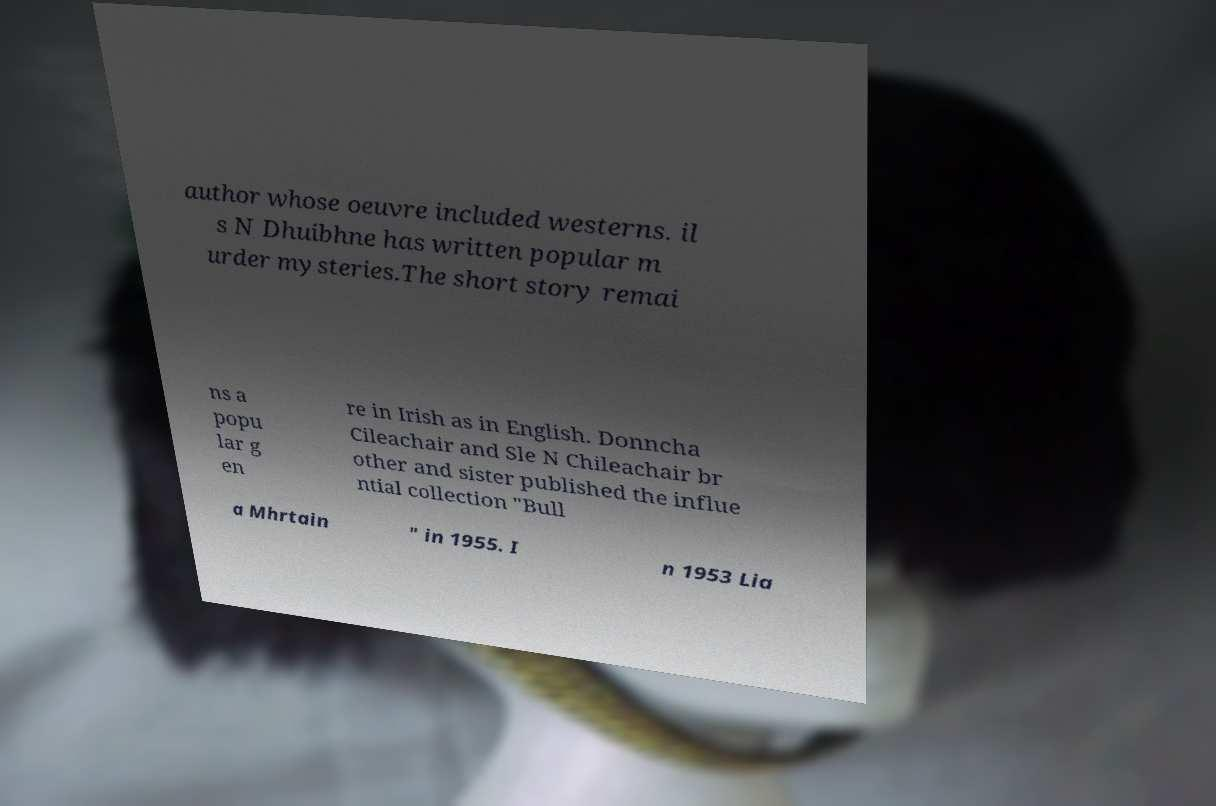What messages or text are displayed in this image? I need them in a readable, typed format. author whose oeuvre included westerns. il s N Dhuibhne has written popular m urder mysteries.The short story remai ns a popu lar g en re in Irish as in English. Donncha Cileachair and Sle N Chileachair br other and sister published the influe ntial collection "Bull a Mhrtain " in 1955. I n 1953 Lia 